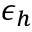Convert formula to latex. <formula><loc_0><loc_0><loc_500><loc_500>\epsilon _ { h }</formula> 